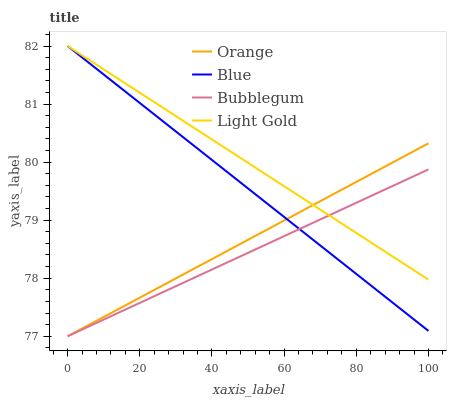Does Bubblegum have the minimum area under the curve?
Answer yes or no. Yes. Does Light Gold have the maximum area under the curve?
Answer yes or no. Yes. Does Blue have the minimum area under the curve?
Answer yes or no. No. Does Blue have the maximum area under the curve?
Answer yes or no. No. Is Light Gold the smoothest?
Answer yes or no. Yes. Is Blue the roughest?
Answer yes or no. Yes. Is Blue the smoothest?
Answer yes or no. No. Is Light Gold the roughest?
Answer yes or no. No. Does Orange have the lowest value?
Answer yes or no. Yes. Does Blue have the lowest value?
Answer yes or no. No. Does Light Gold have the highest value?
Answer yes or no. Yes. Does Bubblegum have the highest value?
Answer yes or no. No. Does Orange intersect Blue?
Answer yes or no. Yes. Is Orange less than Blue?
Answer yes or no. No. Is Orange greater than Blue?
Answer yes or no. No. 